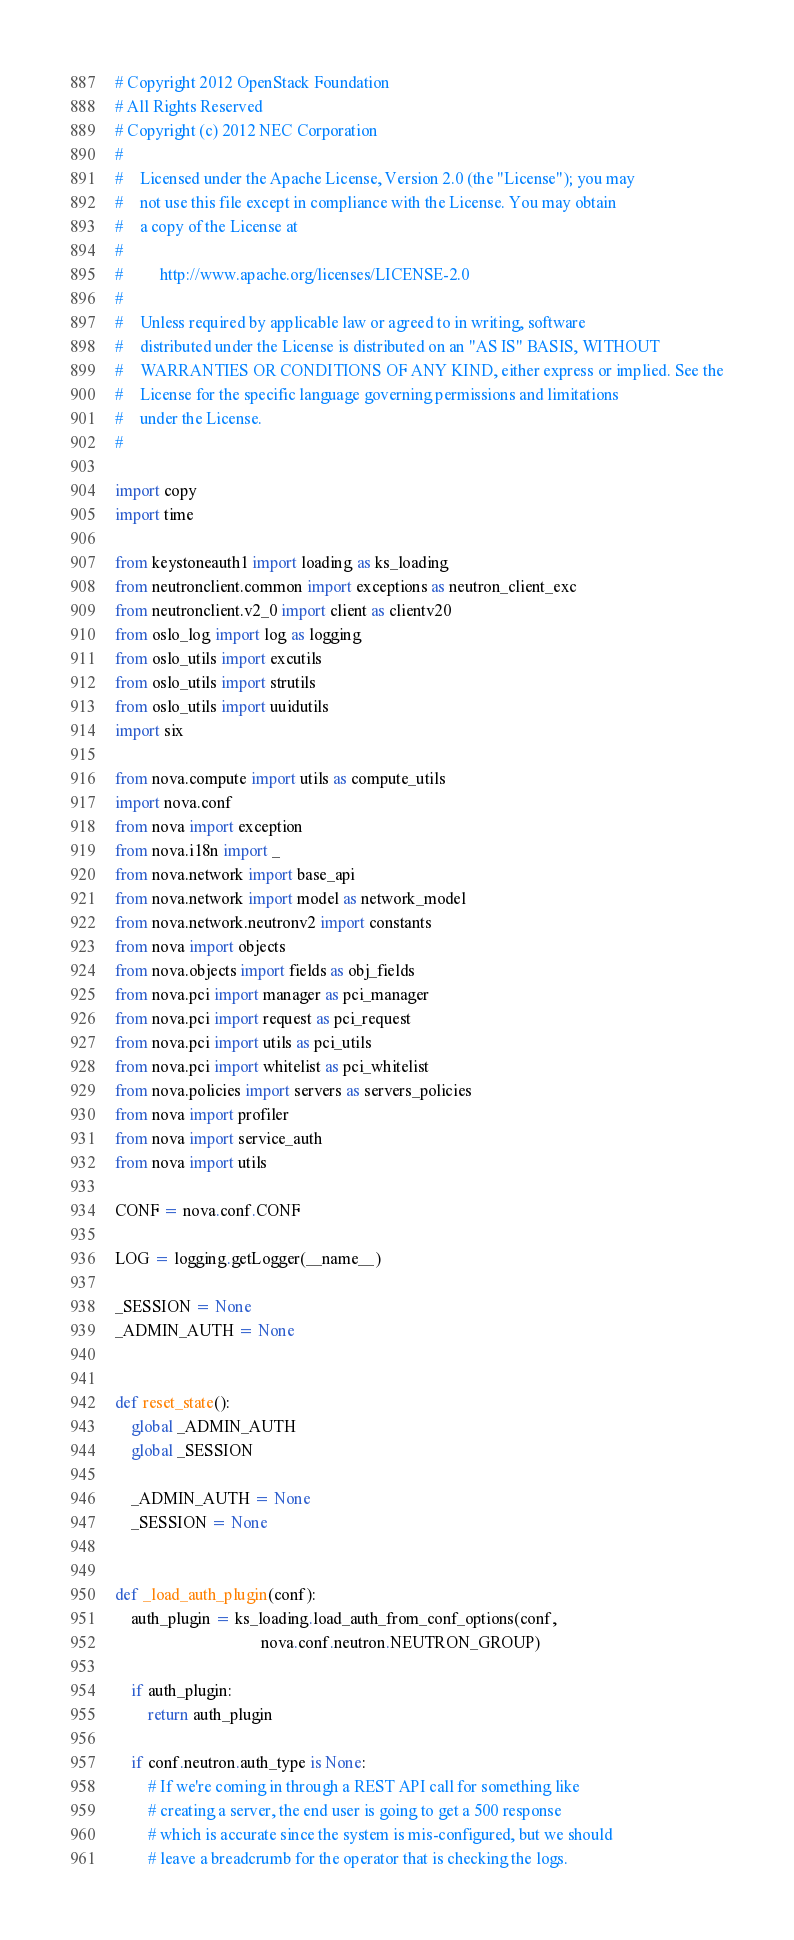Convert code to text. <code><loc_0><loc_0><loc_500><loc_500><_Python_># Copyright 2012 OpenStack Foundation
# All Rights Reserved
# Copyright (c) 2012 NEC Corporation
#
#    Licensed under the Apache License, Version 2.0 (the "License"); you may
#    not use this file except in compliance with the License. You may obtain
#    a copy of the License at
#
#         http://www.apache.org/licenses/LICENSE-2.0
#
#    Unless required by applicable law or agreed to in writing, software
#    distributed under the License is distributed on an "AS IS" BASIS, WITHOUT
#    WARRANTIES OR CONDITIONS OF ANY KIND, either express or implied. See the
#    License for the specific language governing permissions and limitations
#    under the License.
#

import copy
import time

from keystoneauth1 import loading as ks_loading
from neutronclient.common import exceptions as neutron_client_exc
from neutronclient.v2_0 import client as clientv20
from oslo_log import log as logging
from oslo_utils import excutils
from oslo_utils import strutils
from oslo_utils import uuidutils
import six

from nova.compute import utils as compute_utils
import nova.conf
from nova import exception
from nova.i18n import _
from nova.network import base_api
from nova.network import model as network_model
from nova.network.neutronv2 import constants
from nova import objects
from nova.objects import fields as obj_fields
from nova.pci import manager as pci_manager
from nova.pci import request as pci_request
from nova.pci import utils as pci_utils
from nova.pci import whitelist as pci_whitelist
from nova.policies import servers as servers_policies
from nova import profiler
from nova import service_auth
from nova import utils

CONF = nova.conf.CONF

LOG = logging.getLogger(__name__)

_SESSION = None
_ADMIN_AUTH = None


def reset_state():
    global _ADMIN_AUTH
    global _SESSION

    _ADMIN_AUTH = None
    _SESSION = None


def _load_auth_plugin(conf):
    auth_plugin = ks_loading.load_auth_from_conf_options(conf,
                                    nova.conf.neutron.NEUTRON_GROUP)

    if auth_plugin:
        return auth_plugin

    if conf.neutron.auth_type is None:
        # If we're coming in through a REST API call for something like
        # creating a server, the end user is going to get a 500 response
        # which is accurate since the system is mis-configured, but we should
        # leave a breadcrumb for the operator that is checking the logs.</code> 